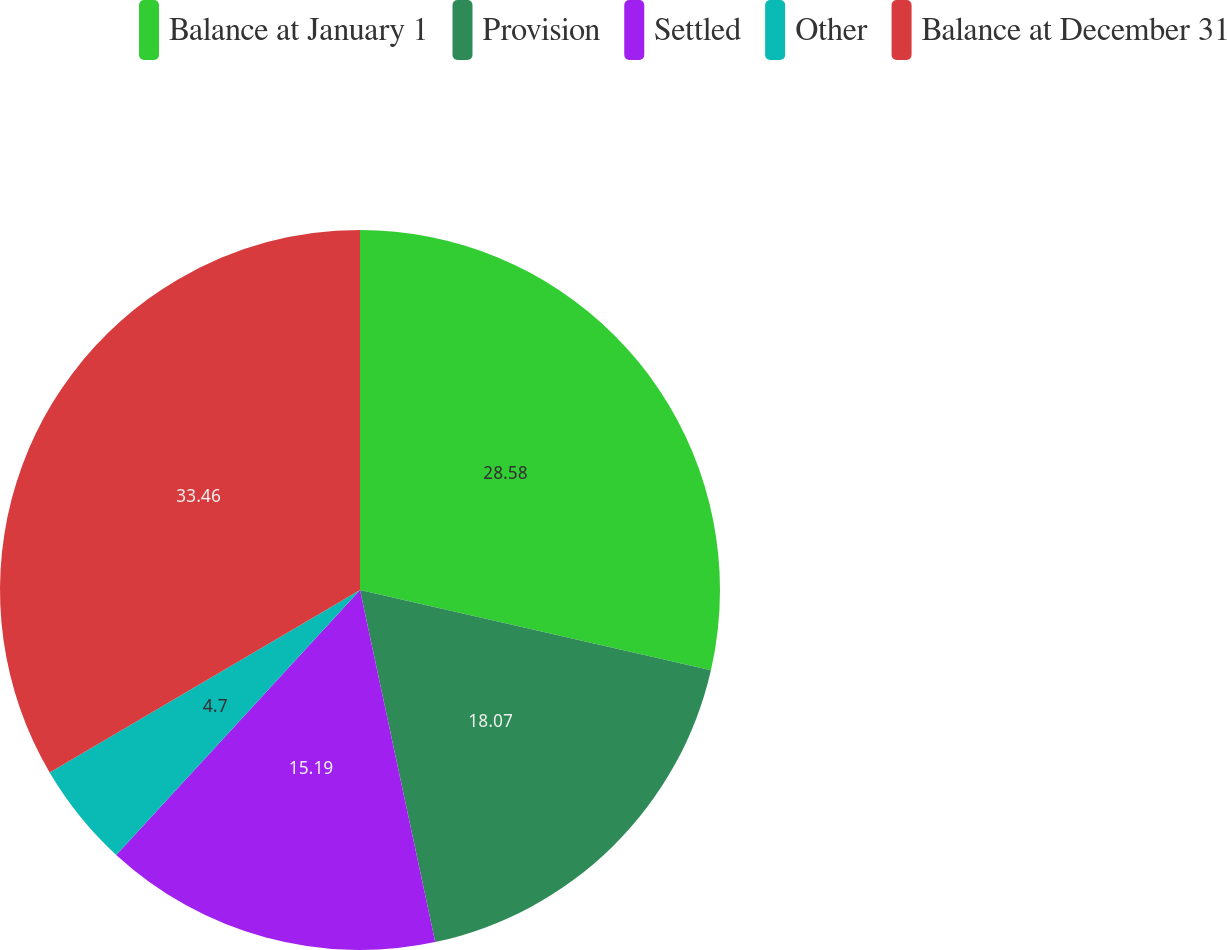Convert chart to OTSL. <chart><loc_0><loc_0><loc_500><loc_500><pie_chart><fcel>Balance at January 1<fcel>Provision<fcel>Settled<fcel>Other<fcel>Balance at December 31<nl><fcel>28.58%<fcel>18.07%<fcel>15.19%<fcel>4.7%<fcel>33.46%<nl></chart> 